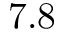Convert formula to latex. <formula><loc_0><loc_0><loc_500><loc_500>7 . 8</formula> 